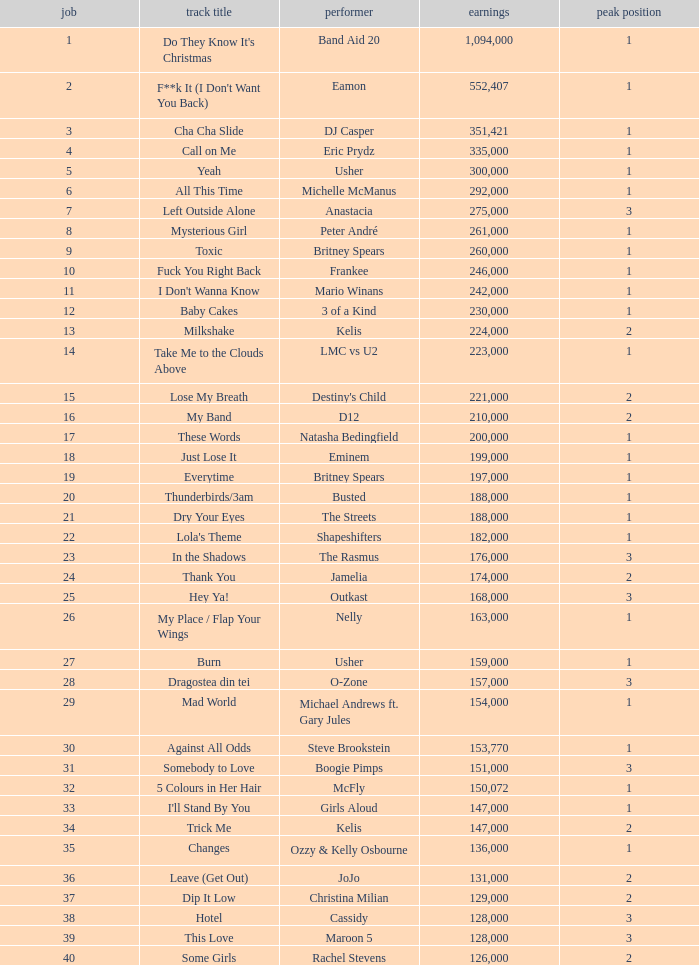What is the most sales by a song with a position higher than 3? None. 